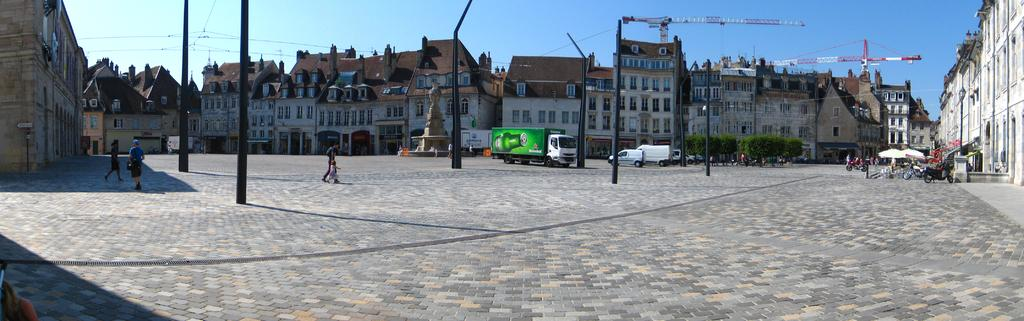What types of structures can be seen in the image? There are buildings in the image. What else can be seen in the image besides buildings? There are poles, wires, vehicles, trees, shadows, and people visible in the image. What is the background of the image? The sky is visible in the background of the image. How many kittens are playing on the plantation in the image? There are no kittens or plantation present in the image. What type of answer can be seen in the image? There is no answer visible in the image. 